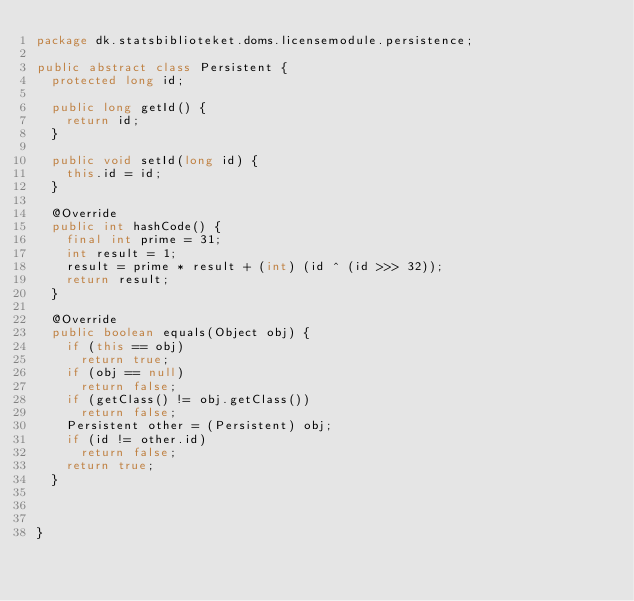Convert code to text. <code><loc_0><loc_0><loc_500><loc_500><_Java_>package dk.statsbiblioteket.doms.licensemodule.persistence;

public abstract class Persistent {
	protected long id;

	public long getId() {
		return id;
	}

	public void setId(long id) {
		this.id = id;
	}

	@Override
	public int hashCode() {
		final int prime = 31;
		int result = 1;
		result = prime * result + (int) (id ^ (id >>> 32));
		return result;
	}

	@Override
	public boolean equals(Object obj) {
		if (this == obj)
			return true;
		if (obj == null)
			return false;
		if (getClass() != obj.getClass())
			return false;
		Persistent other = (Persistent) obj;
		if (id != other.id)
			return false;
		return true;
	}

	
	
}
</code> 